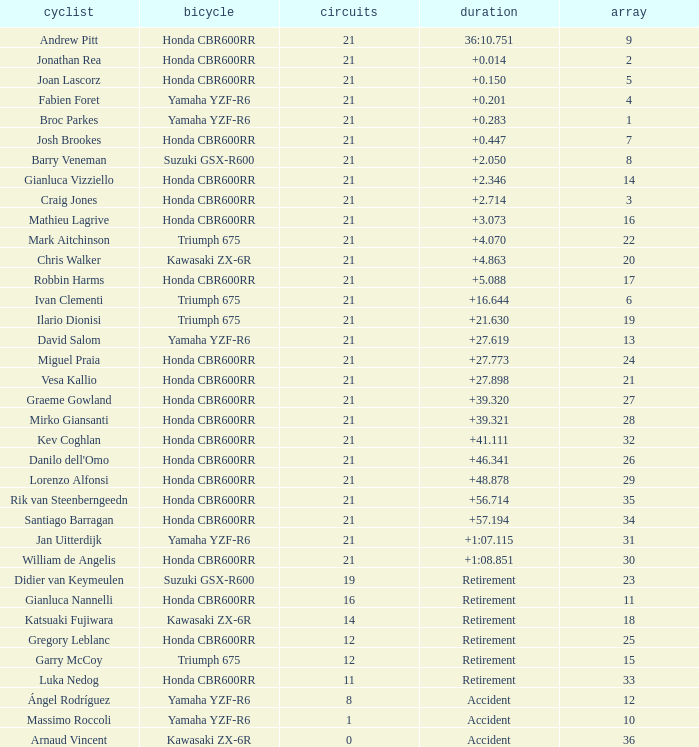What is the most number of laps run by Ilario Dionisi? 21.0. 